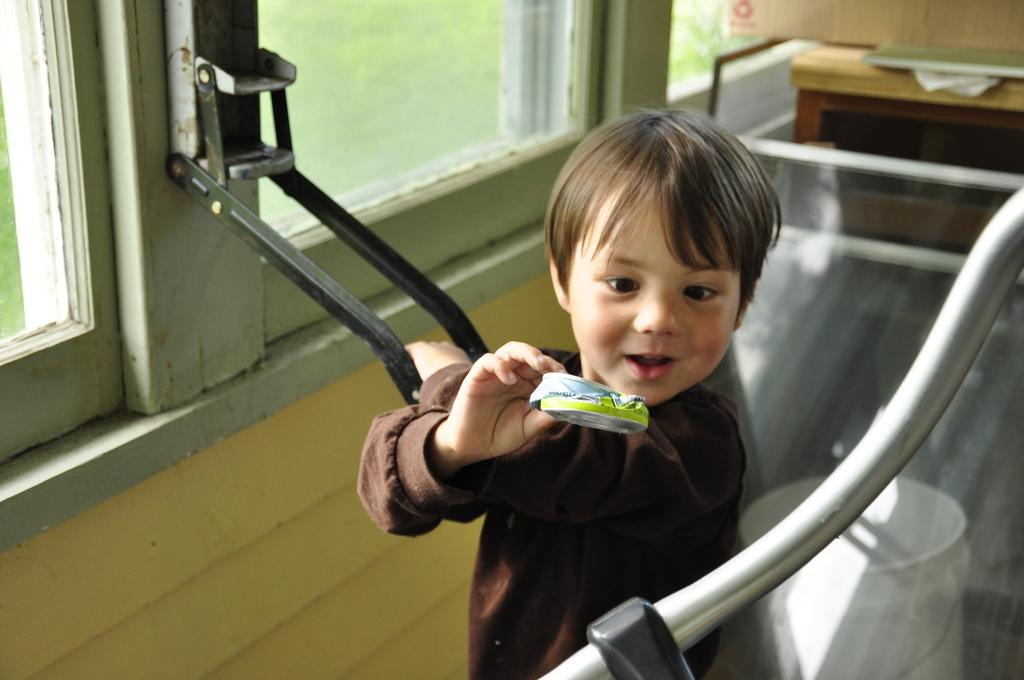Who is the main subject in the image? There is a boy in the image. What is the boy holding in the image? The boy is holding a black color object and a small tin. What can be seen through the windows in the image? The image does not show what can be seen through the windows. What objects are present on the table in the image? The image does not specify the objects on the table. What is the bucket used for in the image? The image does not indicate the purpose of the bucket. What is the pole attached to in the image? The image shows a wall with a pole, but it does not specify what the pole is attached to. What type of disease is the boy suffering from in the image? There is no indication in the image that the boy is suffering from any disease. 